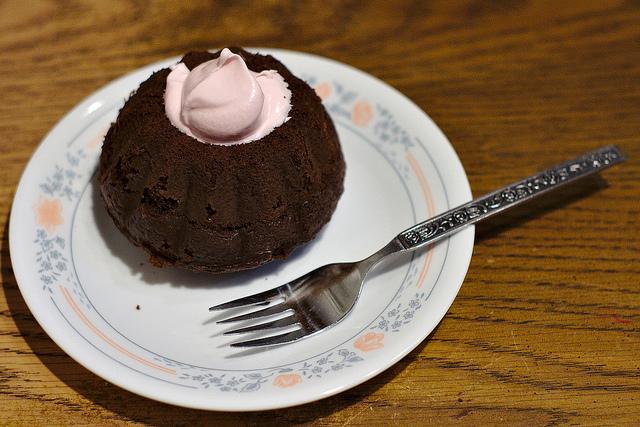Is this a dessert?
Concise answer only. Yes. What is on the plate?
Short answer required. Cake. Where is the fork?
Give a very brief answer. On plate. 